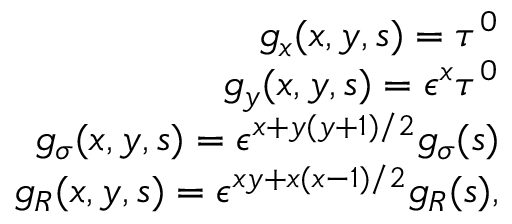Convert formula to latex. <formula><loc_0><loc_0><loc_500><loc_500>\begin{array} { r l r } & { g _ { x } ( x , y , s ) = \tau ^ { 0 } } \\ & { g _ { y } ( x , y , s ) = \epsilon ^ { x } \tau ^ { 0 } } \\ & { g _ { \sigma } ( x , y , s ) = \epsilon ^ { x + y ( y + 1 ) / 2 } g _ { \sigma } ( s ) } \\ & { g _ { R } ( x , y , s ) = \epsilon ^ { x y + x ( x - 1 ) / 2 } g _ { R } ( s ) , } \end{array}</formula> 